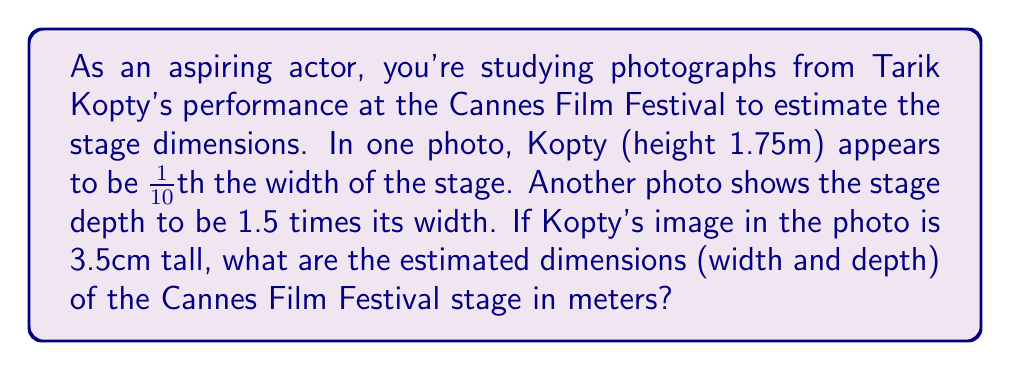Show me your answer to this math problem. Let's approach this step-by-step:

1) First, we need to find the scale of the photograph. We know Kopty's actual height and his height in the photo:
   
   Scale = $\frac{\text{Actual height}}{\text{Photo height}} = \frac{1.75 \text{ m}}{3.5 \text{ cm}} = \frac{175 \text{ cm}}{3.5 \text{ cm}} = 50$

2) Now, if Kopty appears to be 1/10th the width of the stage, we can calculate the stage width:
   
   Stage width = $10 \times \text{Kopty's height in photo} \times \text{Scale}$
                = $10 \times 3.5 \text{ cm} \times 50$
                = $1750 \text{ cm} = 17.5 \text{ m}$

3) We're told the stage depth is 1.5 times its width:
   
   Stage depth = $1.5 \times \text{Stage width}$
                = $1.5 \times 17.5 \text{ m}$
                = $26.25 \text{ m}$

Therefore, the estimated dimensions of the stage are 17.5 m wide and 26.25 m deep.
Answer: 17.5 m × 26.25 m 